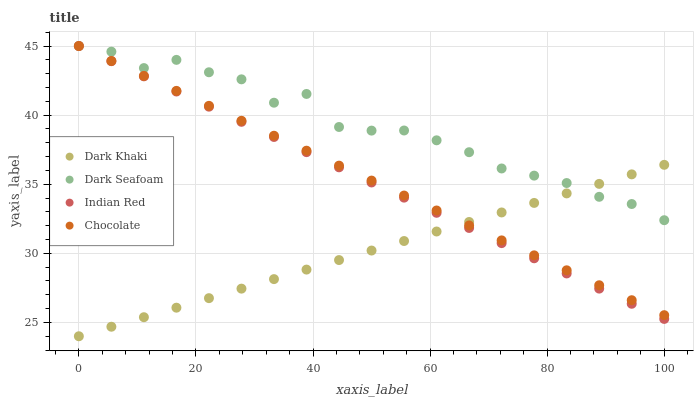Does Dark Khaki have the minimum area under the curve?
Answer yes or no. Yes. Does Dark Seafoam have the maximum area under the curve?
Answer yes or no. Yes. Does Indian Red have the minimum area under the curve?
Answer yes or no. No. Does Indian Red have the maximum area under the curve?
Answer yes or no. No. Is Dark Khaki the smoothest?
Answer yes or no. Yes. Is Dark Seafoam the roughest?
Answer yes or no. Yes. Is Indian Red the smoothest?
Answer yes or no. No. Is Indian Red the roughest?
Answer yes or no. No. Does Dark Khaki have the lowest value?
Answer yes or no. Yes. Does Indian Red have the lowest value?
Answer yes or no. No. Does Chocolate have the highest value?
Answer yes or no. Yes. Does Indian Red intersect Dark Khaki?
Answer yes or no. Yes. Is Indian Red less than Dark Khaki?
Answer yes or no. No. Is Indian Red greater than Dark Khaki?
Answer yes or no. No. 